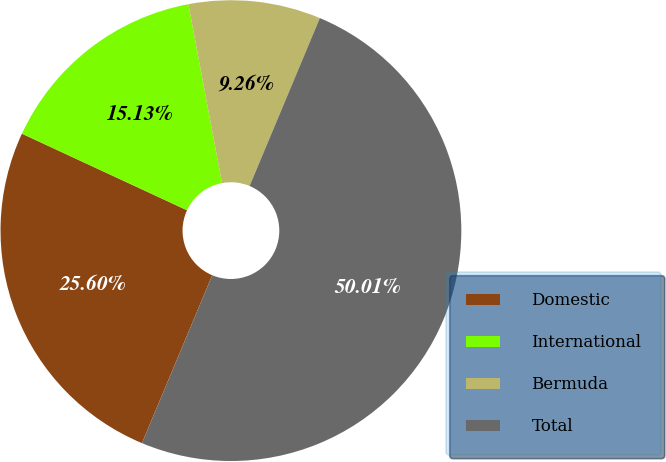Convert chart. <chart><loc_0><loc_0><loc_500><loc_500><pie_chart><fcel>Domestic<fcel>International<fcel>Bermuda<fcel>Total<nl><fcel>25.6%<fcel>15.13%<fcel>9.26%<fcel>50.0%<nl></chart> 